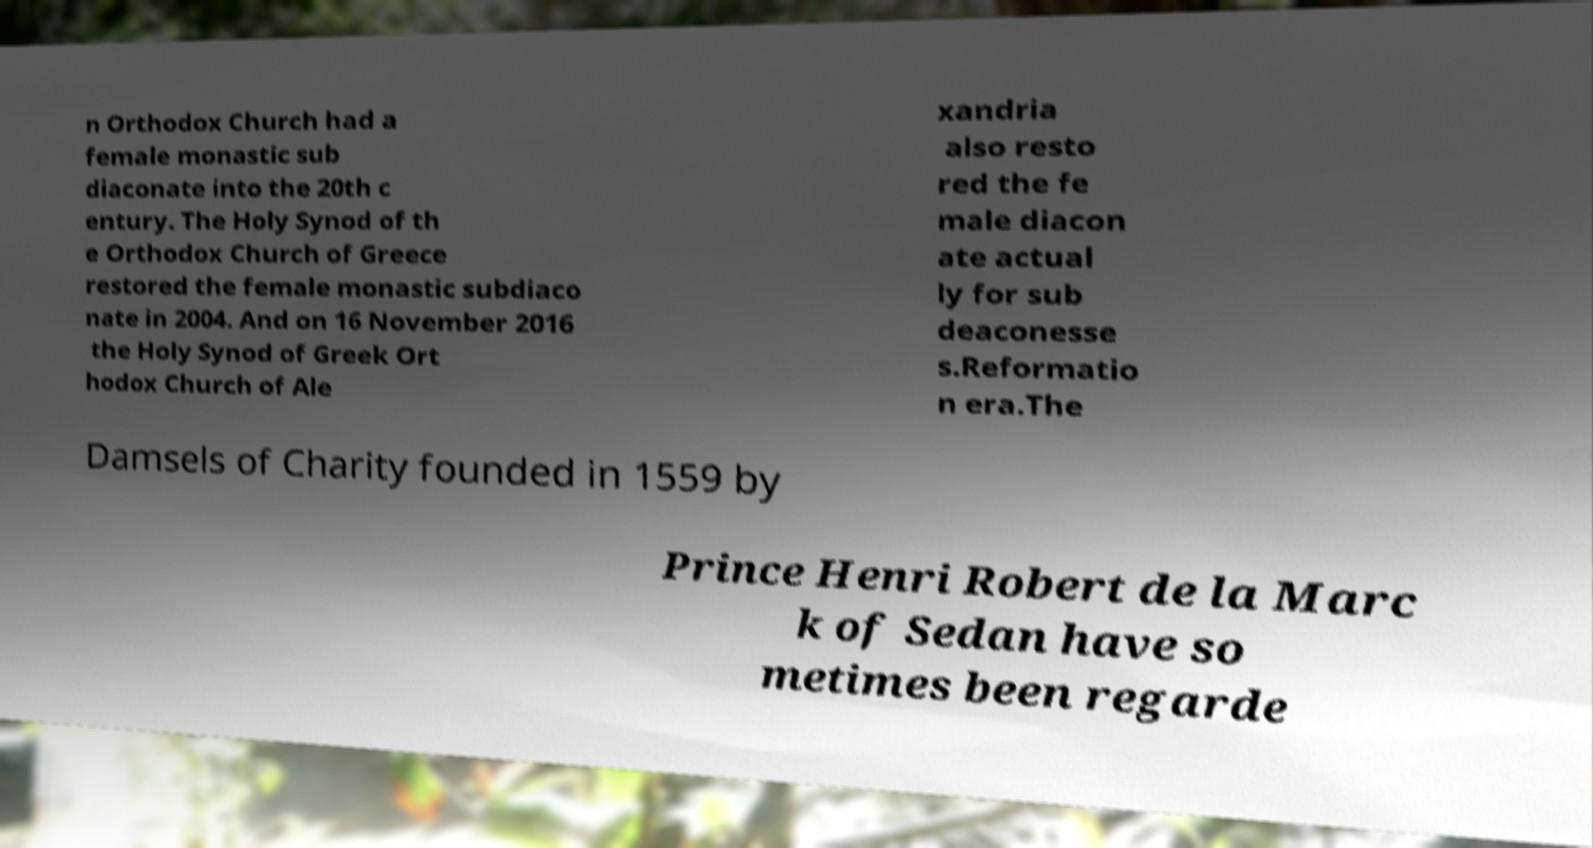There's text embedded in this image that I need extracted. Can you transcribe it verbatim? n Orthodox Church had a female monastic sub diaconate into the 20th c entury. The Holy Synod of th e Orthodox Church of Greece restored the female monastic subdiaco nate in 2004. And on 16 November 2016 the Holy Synod of Greek Ort hodox Church of Ale xandria also resto red the fe male diacon ate actual ly for sub deaconesse s.Reformatio n era.The Damsels of Charity founded in 1559 by Prince Henri Robert de la Marc k of Sedan have so metimes been regarde 